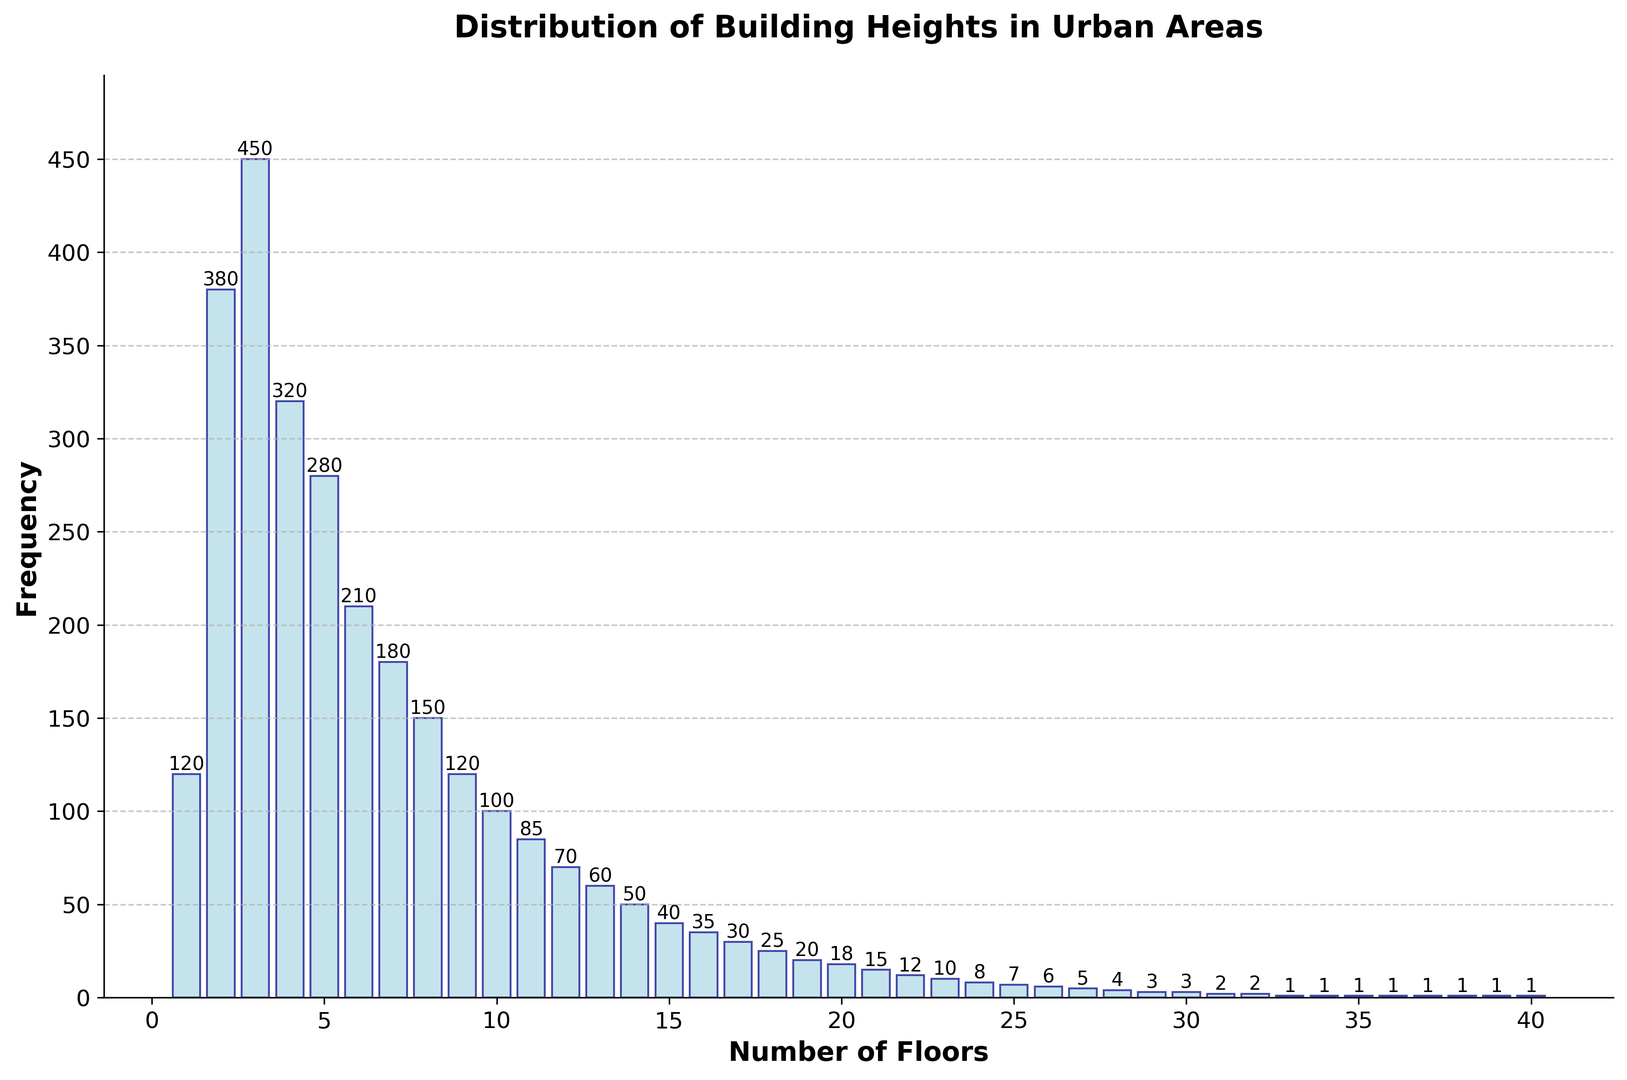What is the most common building height in terms of number of floors? The most common building height is represented by the bar with the highest frequency. Looking at the histogram, the highest bar corresponds to buildings with 3 floors, which has a frequency of 450.
Answer: 3 floors How many buildings have more than 10 floors? Sum the frequencies of buildings with more than 10 floors. These are the buildings with 11, 12, ..., and 40 floors. The frequencies are 85 + 70 + 60 + 50 + 40 + 35 + 30 + 25 + 20 + 18 + 15 + 12 + 10 + 8 + 7 + 6 + 5 + 4 + 3 + 2 + 2 + 1 + 1 + 1 + 1 + 1 + 1 = 512.
Answer: 512 What is the height in terms of the number of floors of the tallest building in this dataset? The tallest building is represented by the bar at the highest number of floors. The histogram shows that the tallest building reached 40 floors.
Answer: 40 floors At which height (number of floors) does the frequency of buildings first drop below 100? Observe the histogram for the first bar where the frequency falls below 100. This occurs at 10 floors, where the frequency is 100.
Answer: 10 floors What is the total number of buildings represented in this histogram? Sum all the frequencies of the bars to get the total number of buildings. The total sum is 120 + 380 + 450 + 320 + 280 + 210 + 180 + 150 + 120 + 100 + 85 + 70 + 60 + 50 + 40 + 35 + 30 + 25 + 20 + 18 + 15 + 12 + 10 + 8 + 7 + 6 + 5 + 4 + 3 + 3 + 2 + 2 + 1 + 1 + 1 + 1 + 1 + 1 = 3091.
Answer: 3091 Are there more buildings with 10 floors or more buildings with 5 floors? Compare the frequencies for buildings with 10 floors and 5 floors. The frequency for 5 floors is 280, and the frequency for 10 floors is 100, meaning there are more buildings with 5 floors.
Answer: 5 floors What is the average number of floors per building? Calculate the average by dividing the total number of floors by the total number of buildings. Total floors = (1*120 + 2*380 + 3*450 + ... + 40*1). Total buildings = 3091. Sum of floors = 1*120 + 2*380 + 3*450 + 4*320 + 5*280 + 6*210 + 7*180 + 8*150 + 9*120 + 10*100 + 11*85 + 12*70 + 13*60 + 14*50 + 15*40 + 16*35 + 17*30 + 18*25 + 19*20 + 20*18 + 21*15 + 22*12 + 23*10 + 24*8 + 25*7 + 26*6 + 27*5 + 28*4 + 29*3 + 30*3 + 31*2 + 32*2 + 33*1 + 34*1 + 35*1 + 36*1 + 37*1 + 38*1 + 39*1 + 40*1 = 32843. Average = 32843 / 3091 = 10.63.
Answer: 10.63 floors 